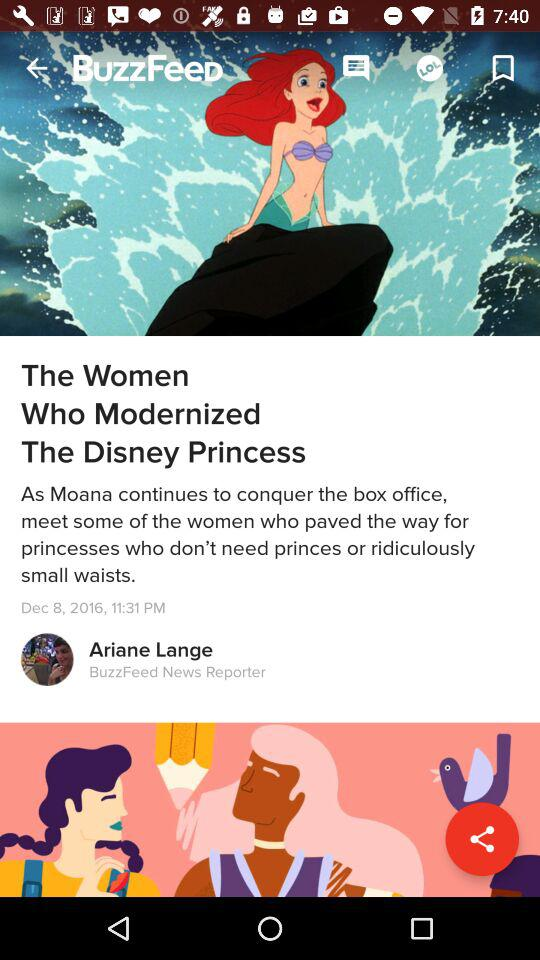What's the published date of the article "The Woman Who Modernized The Disney Princess"? The date is December 8, 2016. 